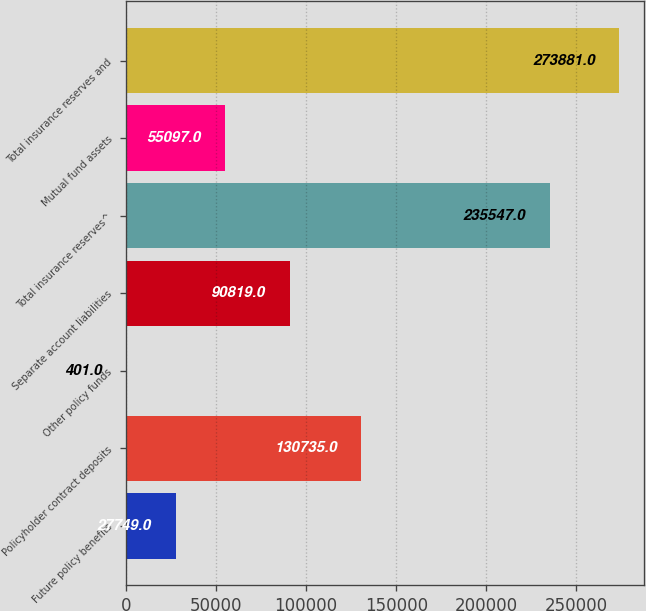Convert chart. <chart><loc_0><loc_0><loc_500><loc_500><bar_chart><fcel>Future policy benefits<fcel>Policyholder contract deposits<fcel>Other policy funds<fcel>Separate account liabilities<fcel>Total insurance reserves^<fcel>Mutual fund assets<fcel>Total insurance reserves and<nl><fcel>27749<fcel>130735<fcel>401<fcel>90819<fcel>235547<fcel>55097<fcel>273881<nl></chart> 